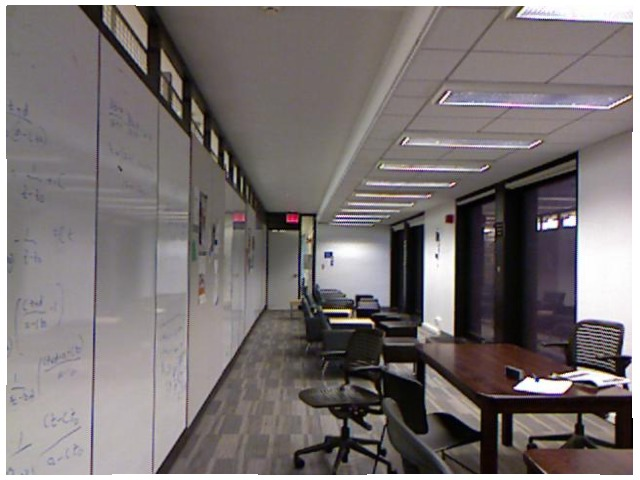<image>
Is the white board behind the chair? No. The white board is not behind the chair. From this viewpoint, the white board appears to be positioned elsewhere in the scene. Is the window above the whiteboard? Yes. The window is positioned above the whiteboard in the vertical space, higher up in the scene. 